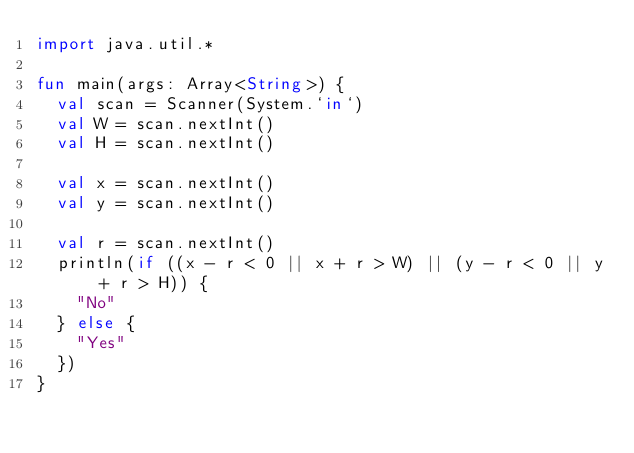Convert code to text. <code><loc_0><loc_0><loc_500><loc_500><_Kotlin_>import java.util.*

fun main(args: Array<String>) {
	val scan = Scanner(System.`in`)
	val W = scan.nextInt()
	val H = scan.nextInt()

	val x = scan.nextInt()
	val y = scan.nextInt()

	val r = scan.nextInt()
	println(if ((x - r < 0 || x + r > W) || (y - r < 0 || y + r > H)) {
		"No"
	} else {
		"Yes"
	})
}
</code> 